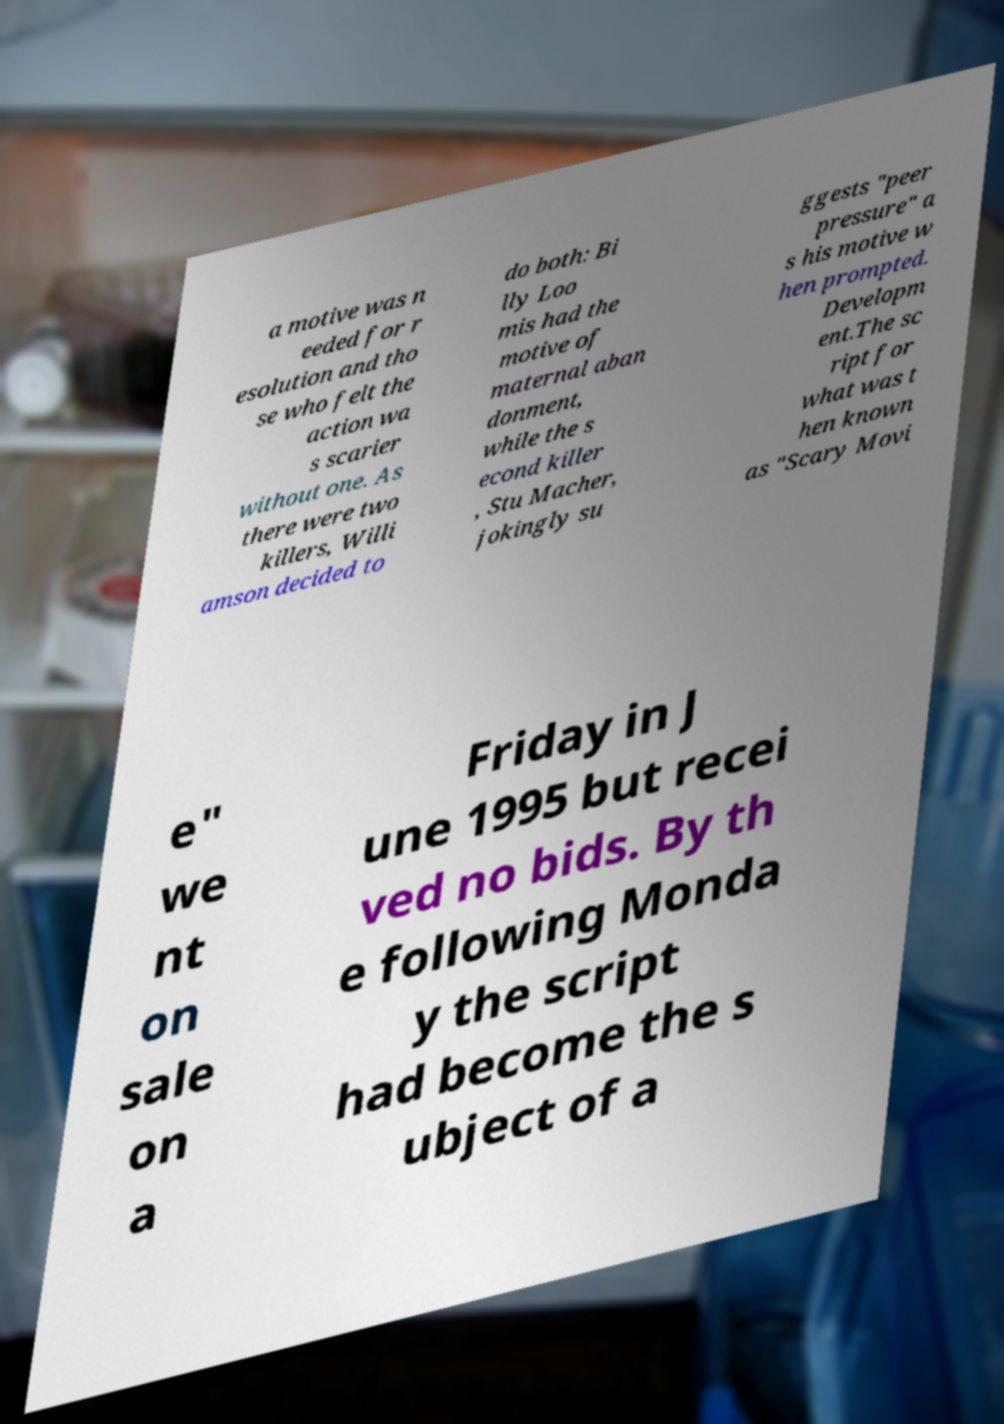Please identify and transcribe the text found in this image. a motive was n eeded for r esolution and tho se who felt the action wa s scarier without one. As there were two killers, Willi amson decided to do both: Bi lly Loo mis had the motive of maternal aban donment, while the s econd killer , Stu Macher, jokingly su ggests "peer pressure" a s his motive w hen prompted. Developm ent.The sc ript for what was t hen known as "Scary Movi e" we nt on sale on a Friday in J une 1995 but recei ved no bids. By th e following Monda y the script had become the s ubject of a 